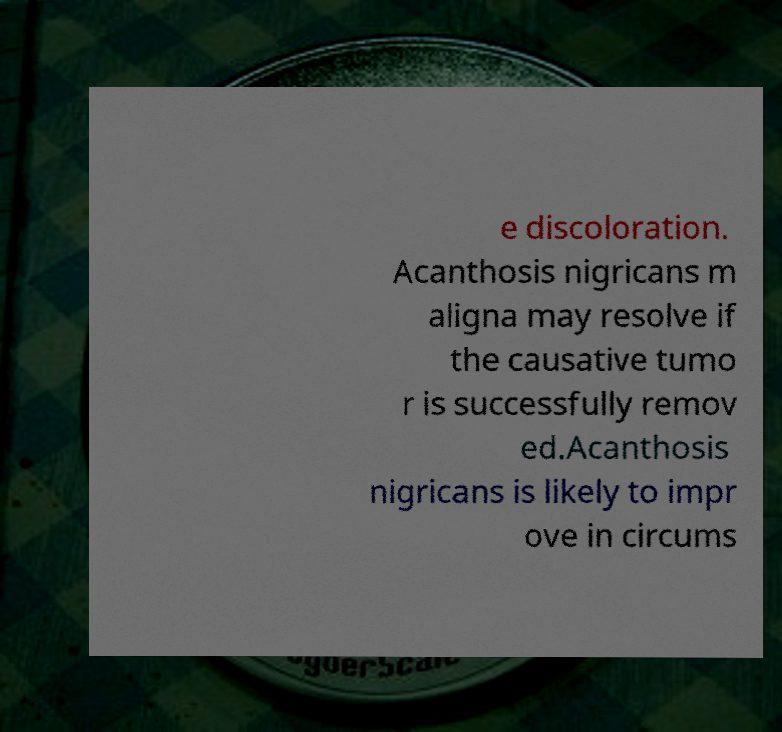Could you assist in decoding the text presented in this image and type it out clearly? e discoloration. Acanthosis nigricans m aligna may resolve if the causative tumo r is successfully remov ed.Acanthosis nigricans is likely to impr ove in circums 